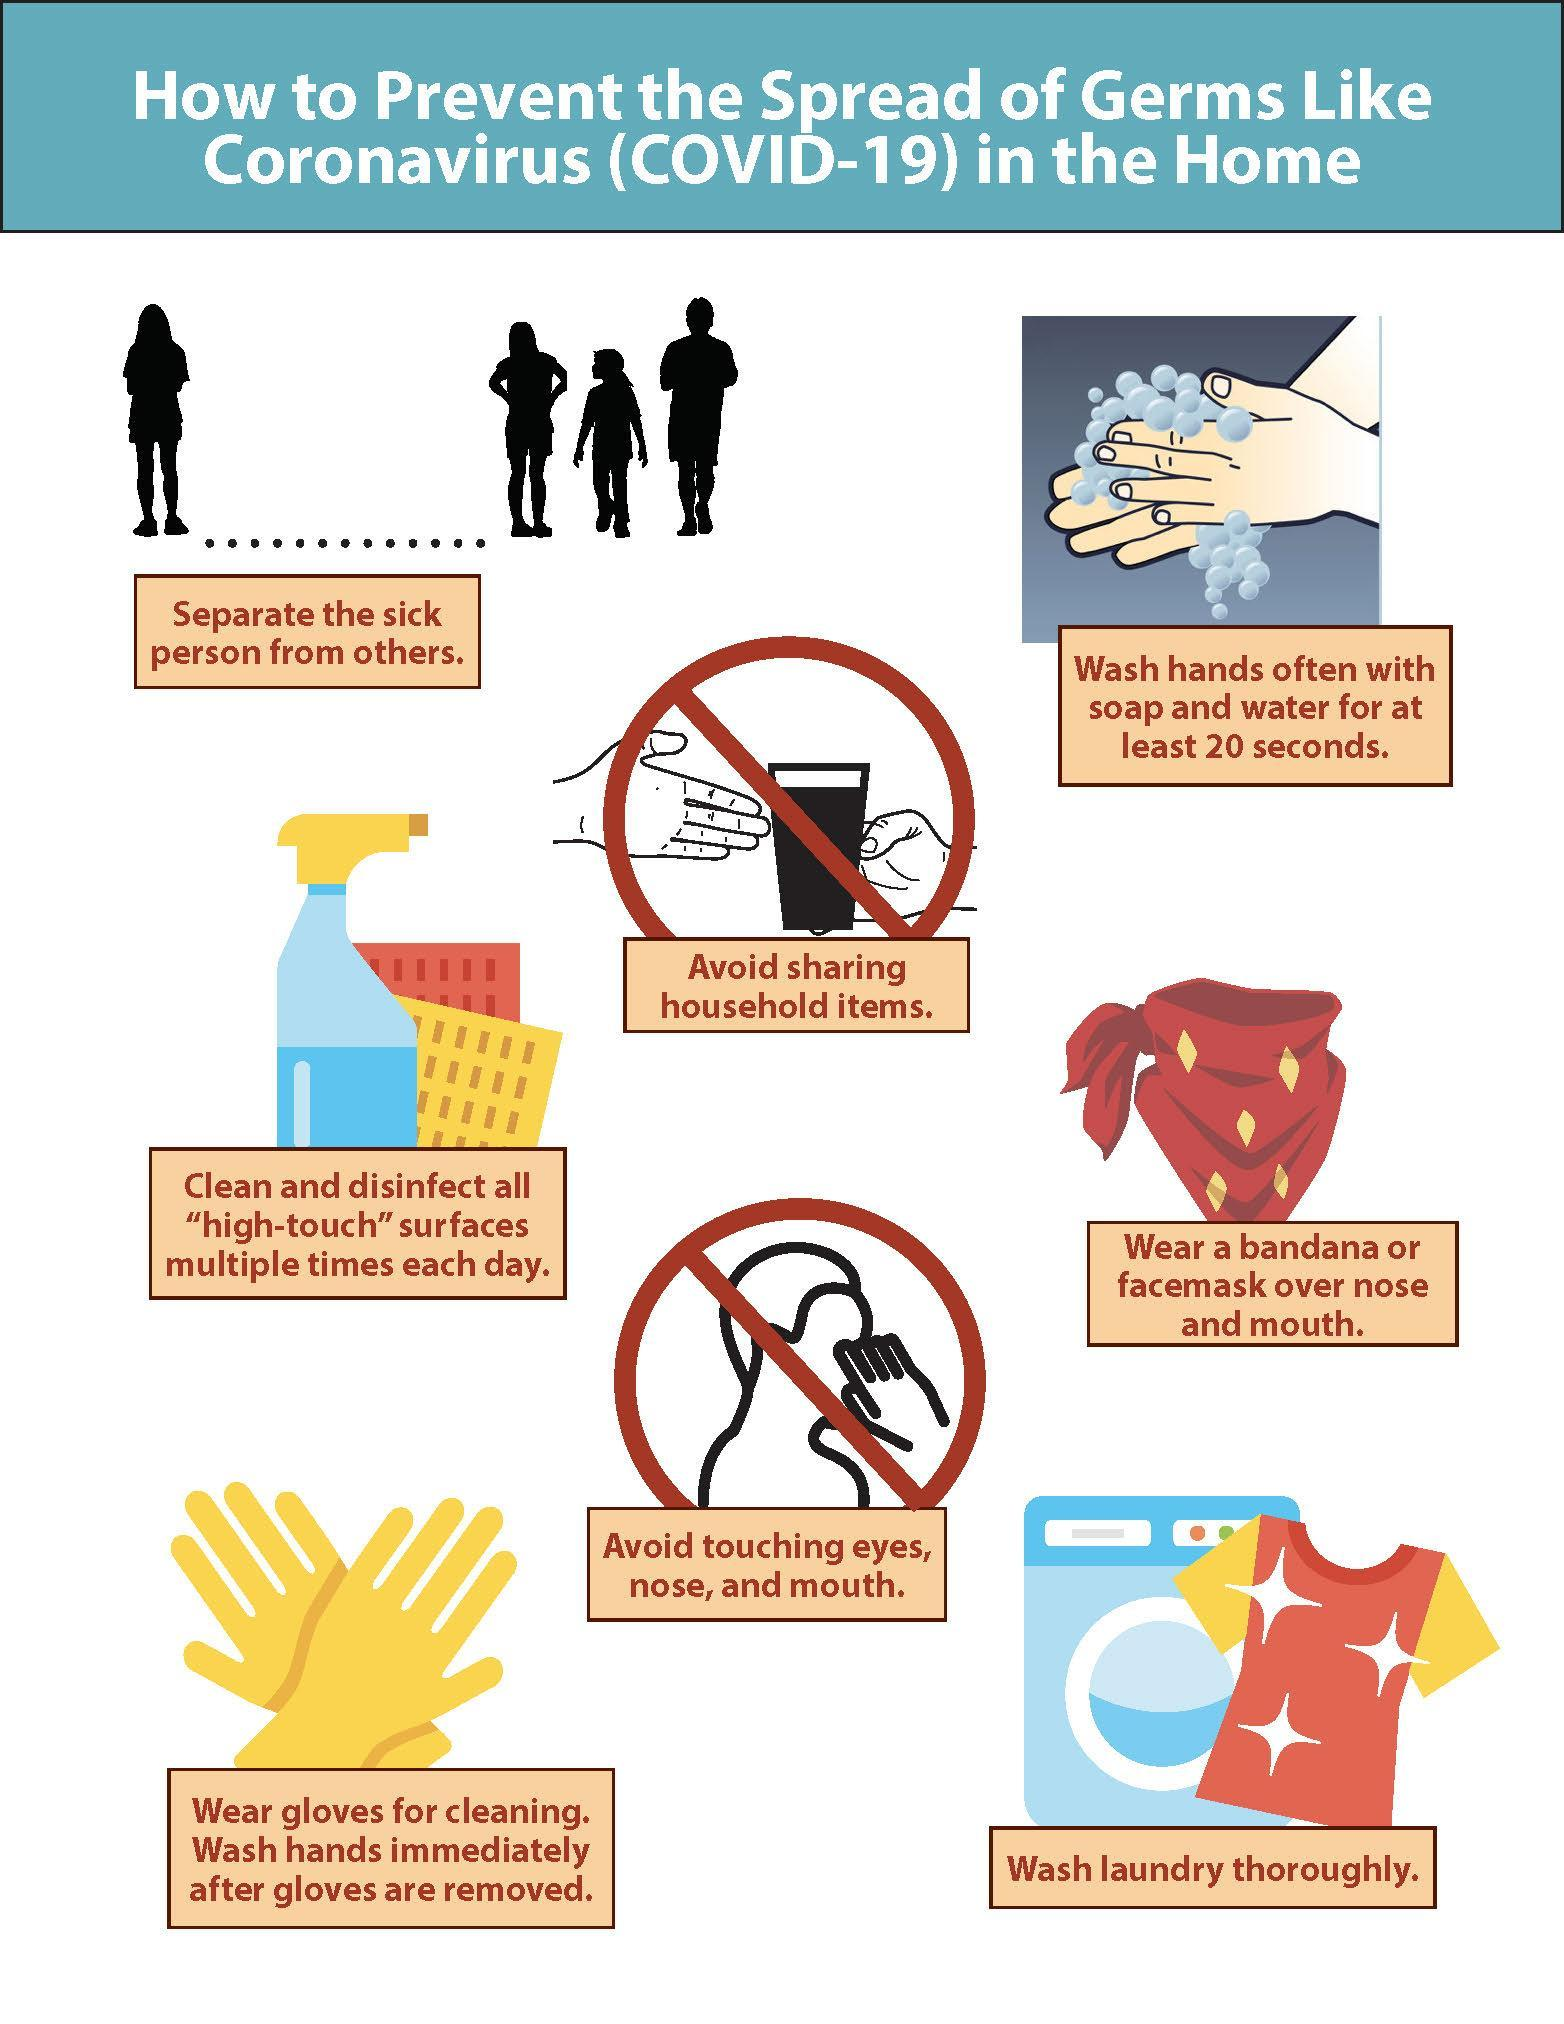How many tips mention about things to avoid?
Answer the question with a short phrase. 2 How many tips to prevent the spread of Coronavirus germs are mentioned in this infographic? 8 